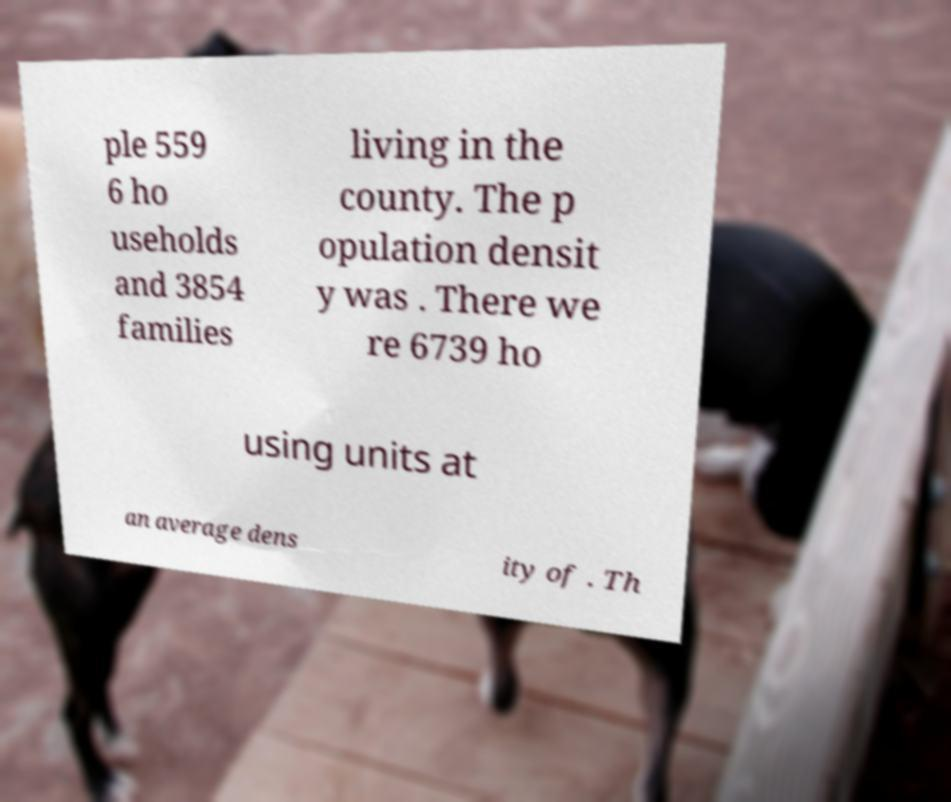Can you read and provide the text displayed in the image?This photo seems to have some interesting text. Can you extract and type it out for me? ple 559 6 ho useholds and 3854 families living in the county. The p opulation densit y was . There we re 6739 ho using units at an average dens ity of . Th 